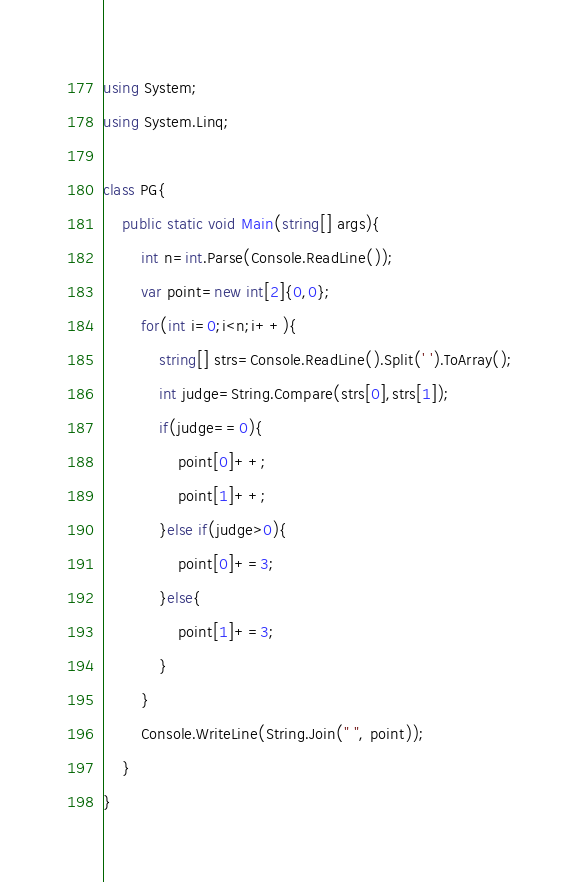<code> <loc_0><loc_0><loc_500><loc_500><_C#_>using System;
using System.Linq;

class PG{
    public static void Main(string[] args){
        int n=int.Parse(Console.ReadLine());
        var point=new int[2]{0,0};
        for(int i=0;i<n;i++){
            string[] strs=Console.ReadLine().Split(' ').ToArray();
            int judge=String.Compare(strs[0],strs[1]);
            if(judge==0){
                point[0]++;
                point[1]++;
            }else if(judge>0){
                point[0]+=3;
            }else{
                point[1]+=3;
            }
        }
        Console.WriteLine(String.Join(" ", point));
    }
}
</code> 